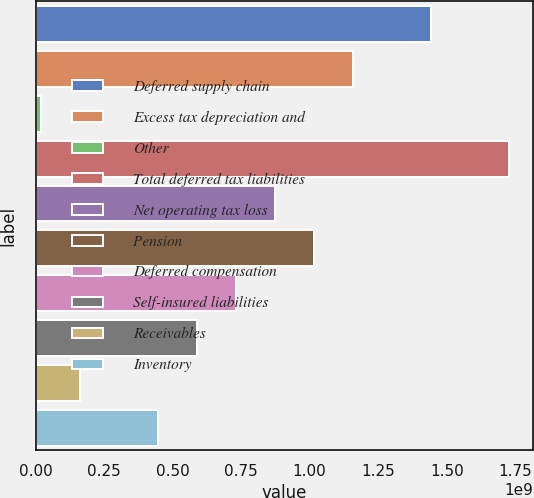Convert chart. <chart><loc_0><loc_0><loc_500><loc_500><bar_chart><fcel>Deferred supply chain<fcel>Excess tax depreciation and<fcel>Other<fcel>Total deferred tax liabilities<fcel>Net operating tax loss<fcel>Pension<fcel>Deferred compensation<fcel>Self-insured liabilities<fcel>Receivables<fcel>Inventory<nl><fcel>1.44399e+09<fcel>1.15932e+09<fcel>2.0601e+07<fcel>1.72867e+09<fcel>8.74637e+08<fcel>1.01698e+09<fcel>7.32298e+08<fcel>5.89958e+08<fcel>1.6294e+08<fcel>4.47619e+08<nl></chart> 